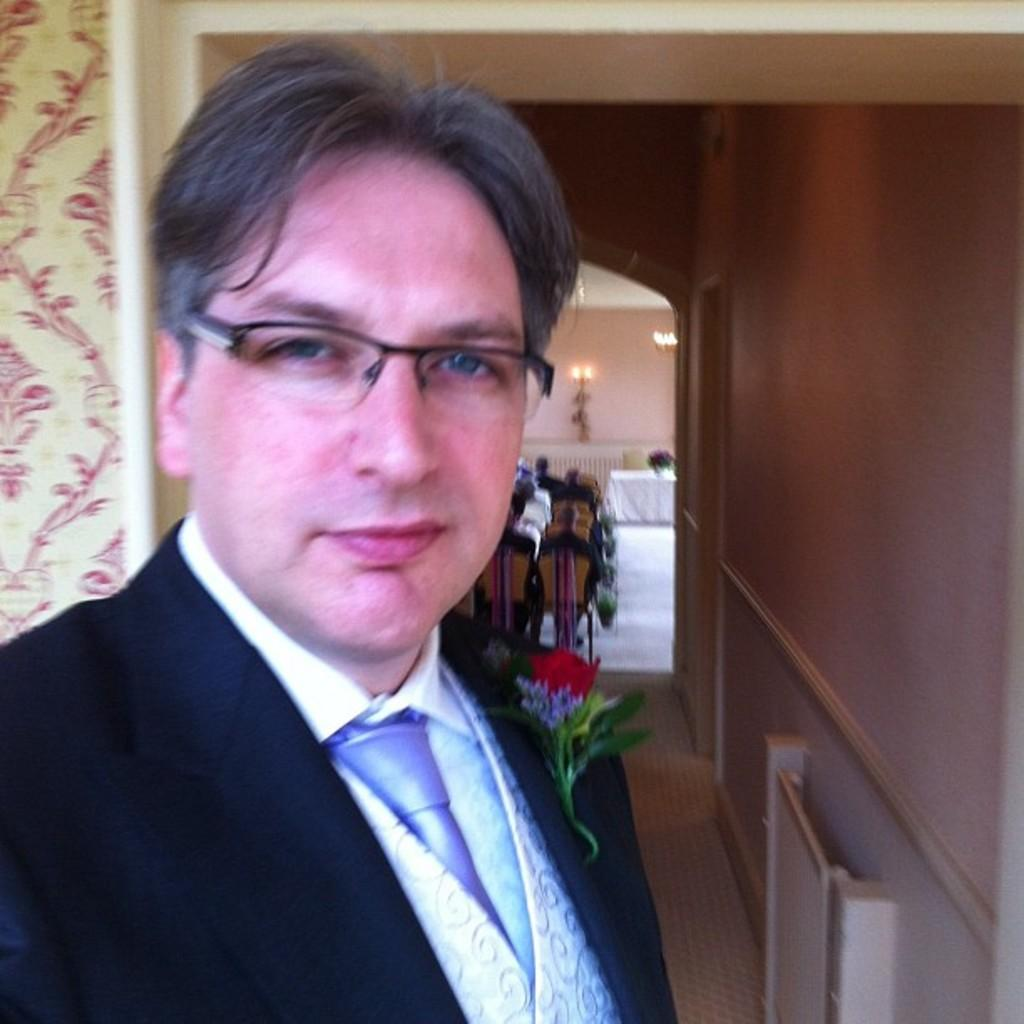Who is the main subject in the image? There is a man in the image. What is the man wearing? The man is wearing a blazer. What can be seen in the background of the image? There are people sitting on chairs and a wall in the background. Can you describe the lighting in the image? There is a light on the wall in the image. What type of crack can be seen on the man's face in the image? There is no crack visible on the man's face in the image. What achievement is the man celebrating in the image? There is no indication of any achievement being celebrated in the image. 